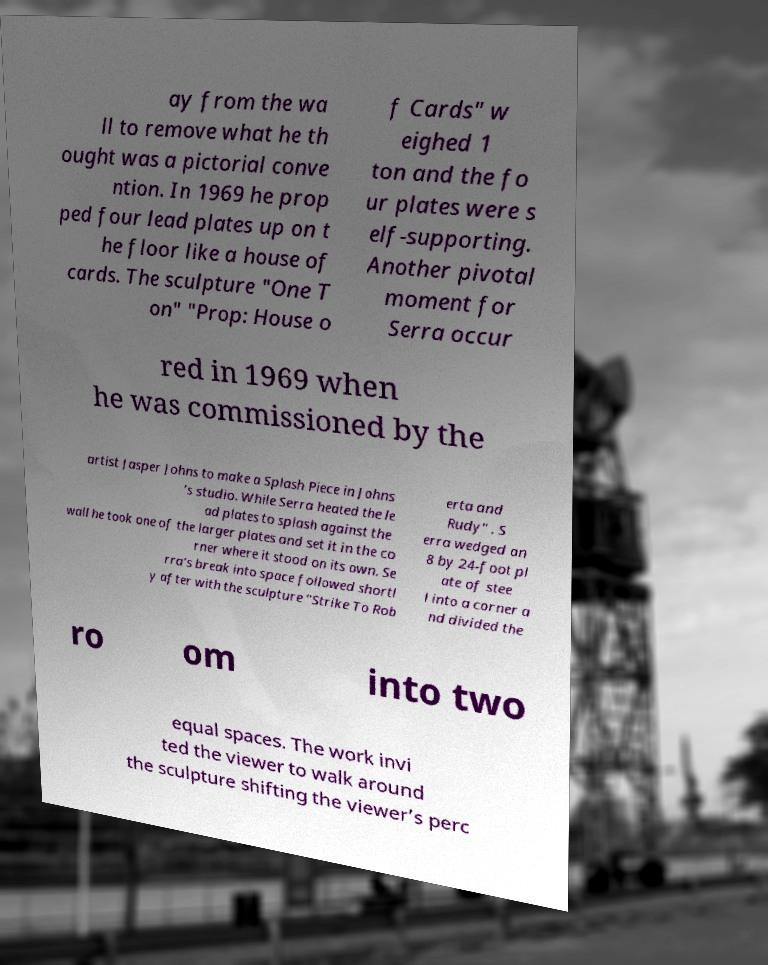Please read and relay the text visible in this image. What does it say? ay from the wa ll to remove what he th ought was a pictorial conve ntion. In 1969 he prop ped four lead plates up on t he floor like a house of cards. The sculpture "One T on" "Prop: House o f Cards" w eighed 1 ton and the fo ur plates were s elf-supporting. Another pivotal moment for Serra occur red in 1969 when he was commissioned by the artist Jasper Johns to make a Splash Piece in Johns ’s studio. While Serra heated the le ad plates to splash against the wall he took one of the larger plates and set it in the co rner where it stood on its own. Se rra’s break into space followed shortl y after with the sculpture "Strike To Rob erta and Rudy" . S erra wedged an 8 by 24-foot pl ate of stee l into a corner a nd divided the ro om into two equal spaces. The work invi ted the viewer to walk around the sculpture shifting the viewer’s perc 